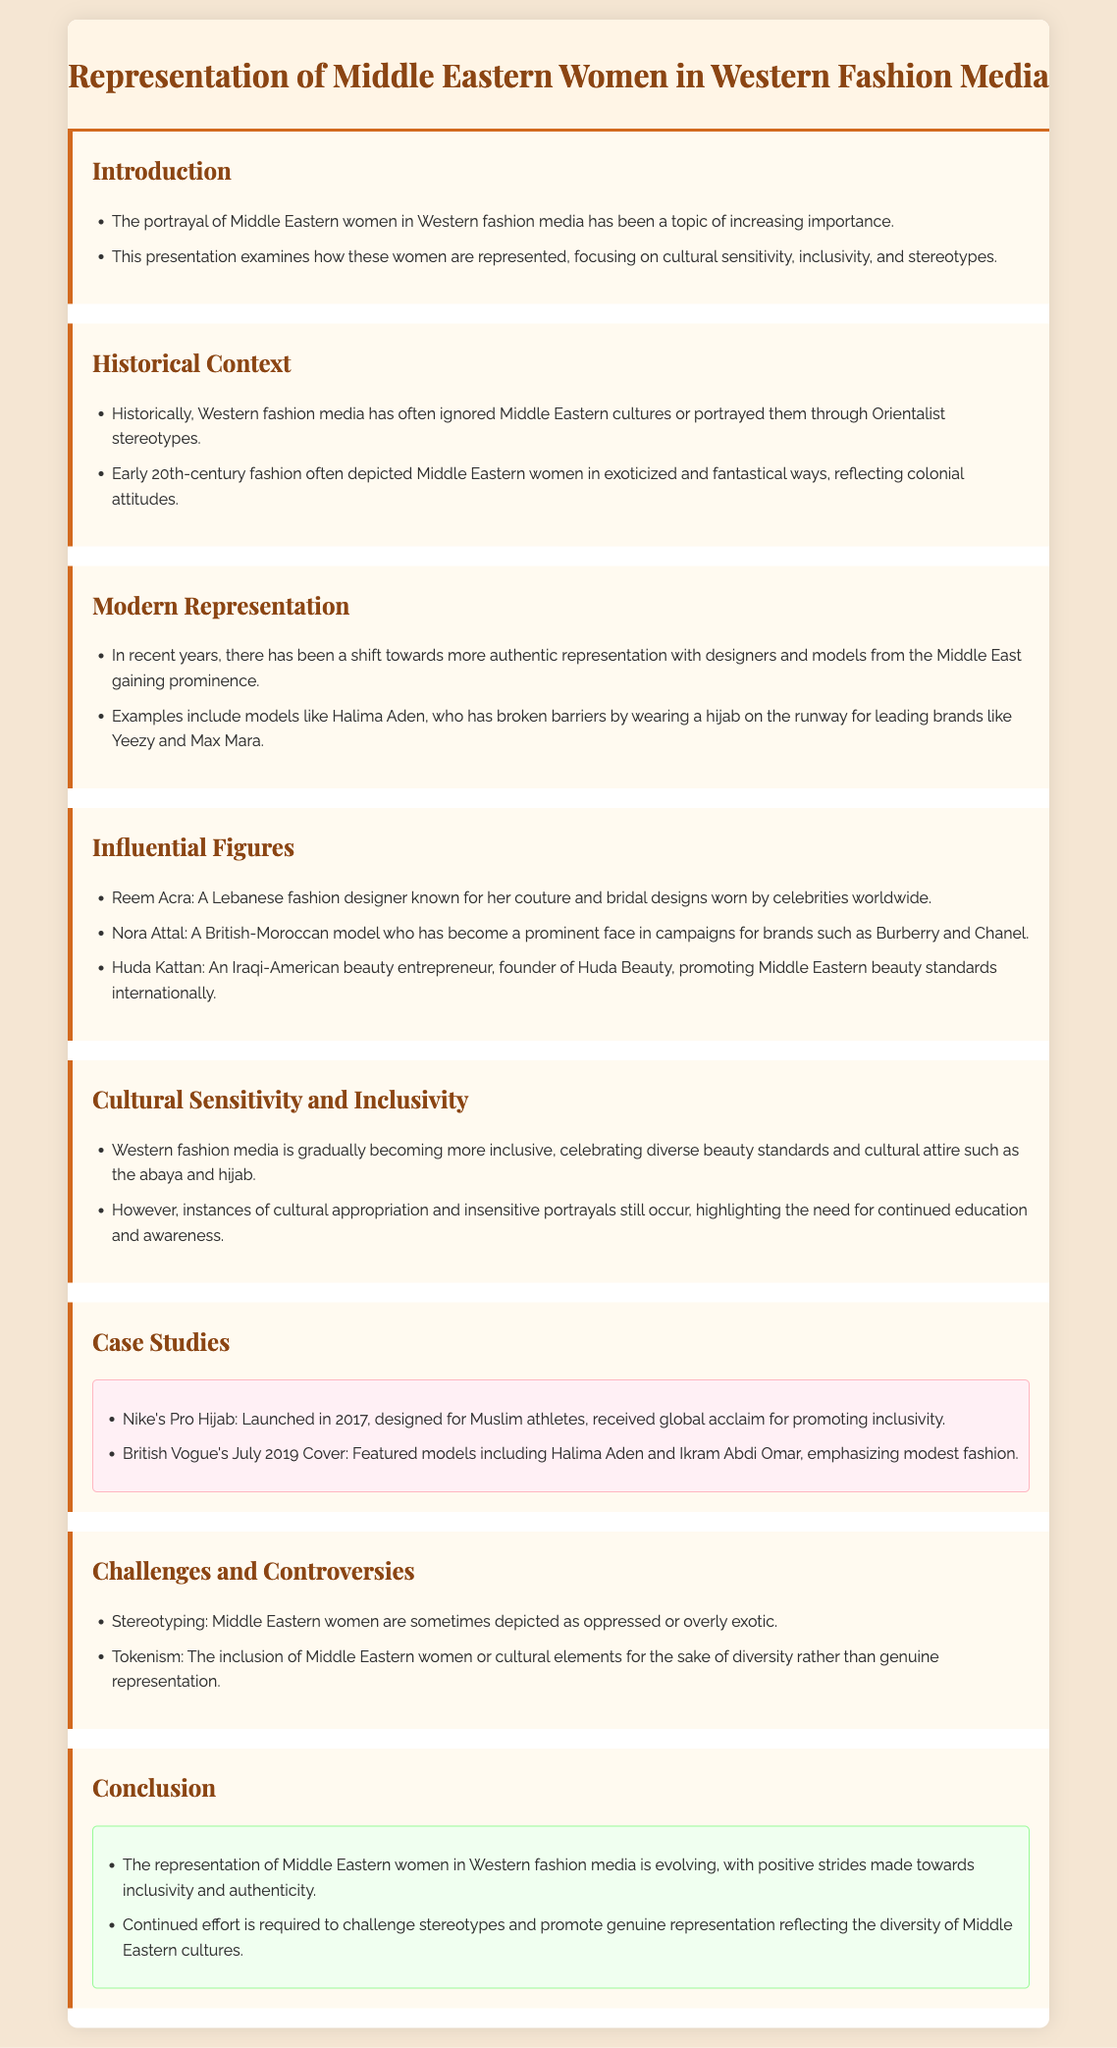What is the main topic of the presentation? The main focus of the presentation is the representation of Middle Eastern women in Western fashion media.
Answer: Representation of Middle Eastern women in Western fashion media Who is Halima Aden? Halima Aden is a model who has gained prominence by wearing a hijab on the runway for leading brands.
Answer: A model What cultural attire is mentioned as being celebrated in Western fashion media? The presentation mentions the abaya and hijab as cultural attire being celebrated.
Answer: Abaya and hijab What company launched the Pro Hijab in 2017? Nike is the company that launched the Pro Hijab designed for Muslim athletes.
Answer: Nike What major issue is highlighted under "Challenges and Controversies"? Stereotyping is a major issue mentioned, depicting Middle Eastern women in a limited manner.
Answer: Stereotyping What significant change is indicated in modern representation of Middle Eastern women? There’s a shift towards more authentic representation with designers and models from the Middle East gaining prominence.
Answer: Authentic representation Who is Huda Kattan? Huda Kattan is an Iraqi-American beauty entrepreneur and founder of Huda Beauty.
Answer: A beauty entrepreneur What is highlighted as still occurring in Western fashion media regarding Middle Eastern representation? Cultural appropriation and insensitive portrayals still occur.
Answer: Cultural appropriation What does the conclusion emphasize regarding the evolution of representation? The conclusion emphasizes that continued effort is required to challenge stereotypes and promote genuine representation.
Answer: Continued effort required 